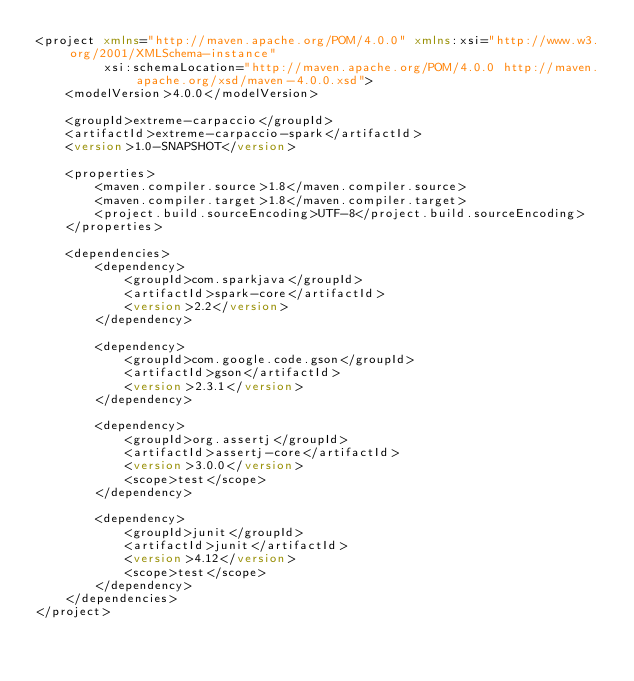Convert code to text. <code><loc_0><loc_0><loc_500><loc_500><_XML_><project xmlns="http://maven.apache.org/POM/4.0.0" xmlns:xsi="http://www.w3.org/2001/XMLSchema-instance"
         xsi:schemaLocation="http://maven.apache.org/POM/4.0.0 http://maven.apache.org/xsd/maven-4.0.0.xsd">
    <modelVersion>4.0.0</modelVersion>

    <groupId>extreme-carpaccio</groupId>
    <artifactId>extreme-carpaccio-spark</artifactId>
    <version>1.0-SNAPSHOT</version>

    <properties>
        <maven.compiler.source>1.8</maven.compiler.source>
        <maven.compiler.target>1.8</maven.compiler.target>
        <project.build.sourceEncoding>UTF-8</project.build.sourceEncoding>
    </properties>

    <dependencies>
        <dependency>
            <groupId>com.sparkjava</groupId>
            <artifactId>spark-core</artifactId>
            <version>2.2</version>
        </dependency>

        <dependency>
            <groupId>com.google.code.gson</groupId>
            <artifactId>gson</artifactId>
            <version>2.3.1</version>
        </dependency>

        <dependency>
            <groupId>org.assertj</groupId>
            <artifactId>assertj-core</artifactId>
            <version>3.0.0</version>
            <scope>test</scope>
        </dependency>

        <dependency>
            <groupId>junit</groupId>
            <artifactId>junit</artifactId>
            <version>4.12</version>
            <scope>test</scope>
        </dependency>
    </dependencies>
</project>
</code> 